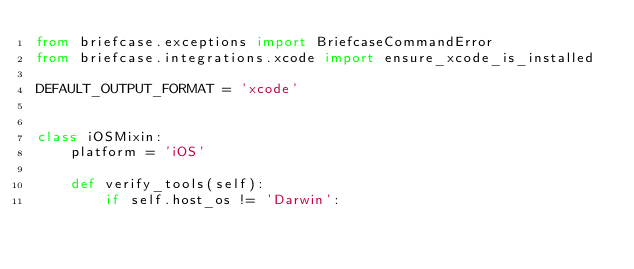<code> <loc_0><loc_0><loc_500><loc_500><_Python_>from briefcase.exceptions import BriefcaseCommandError
from briefcase.integrations.xcode import ensure_xcode_is_installed

DEFAULT_OUTPUT_FORMAT = 'xcode'


class iOSMixin:
    platform = 'iOS'

    def verify_tools(self):
        if self.host_os != 'Darwin':</code> 